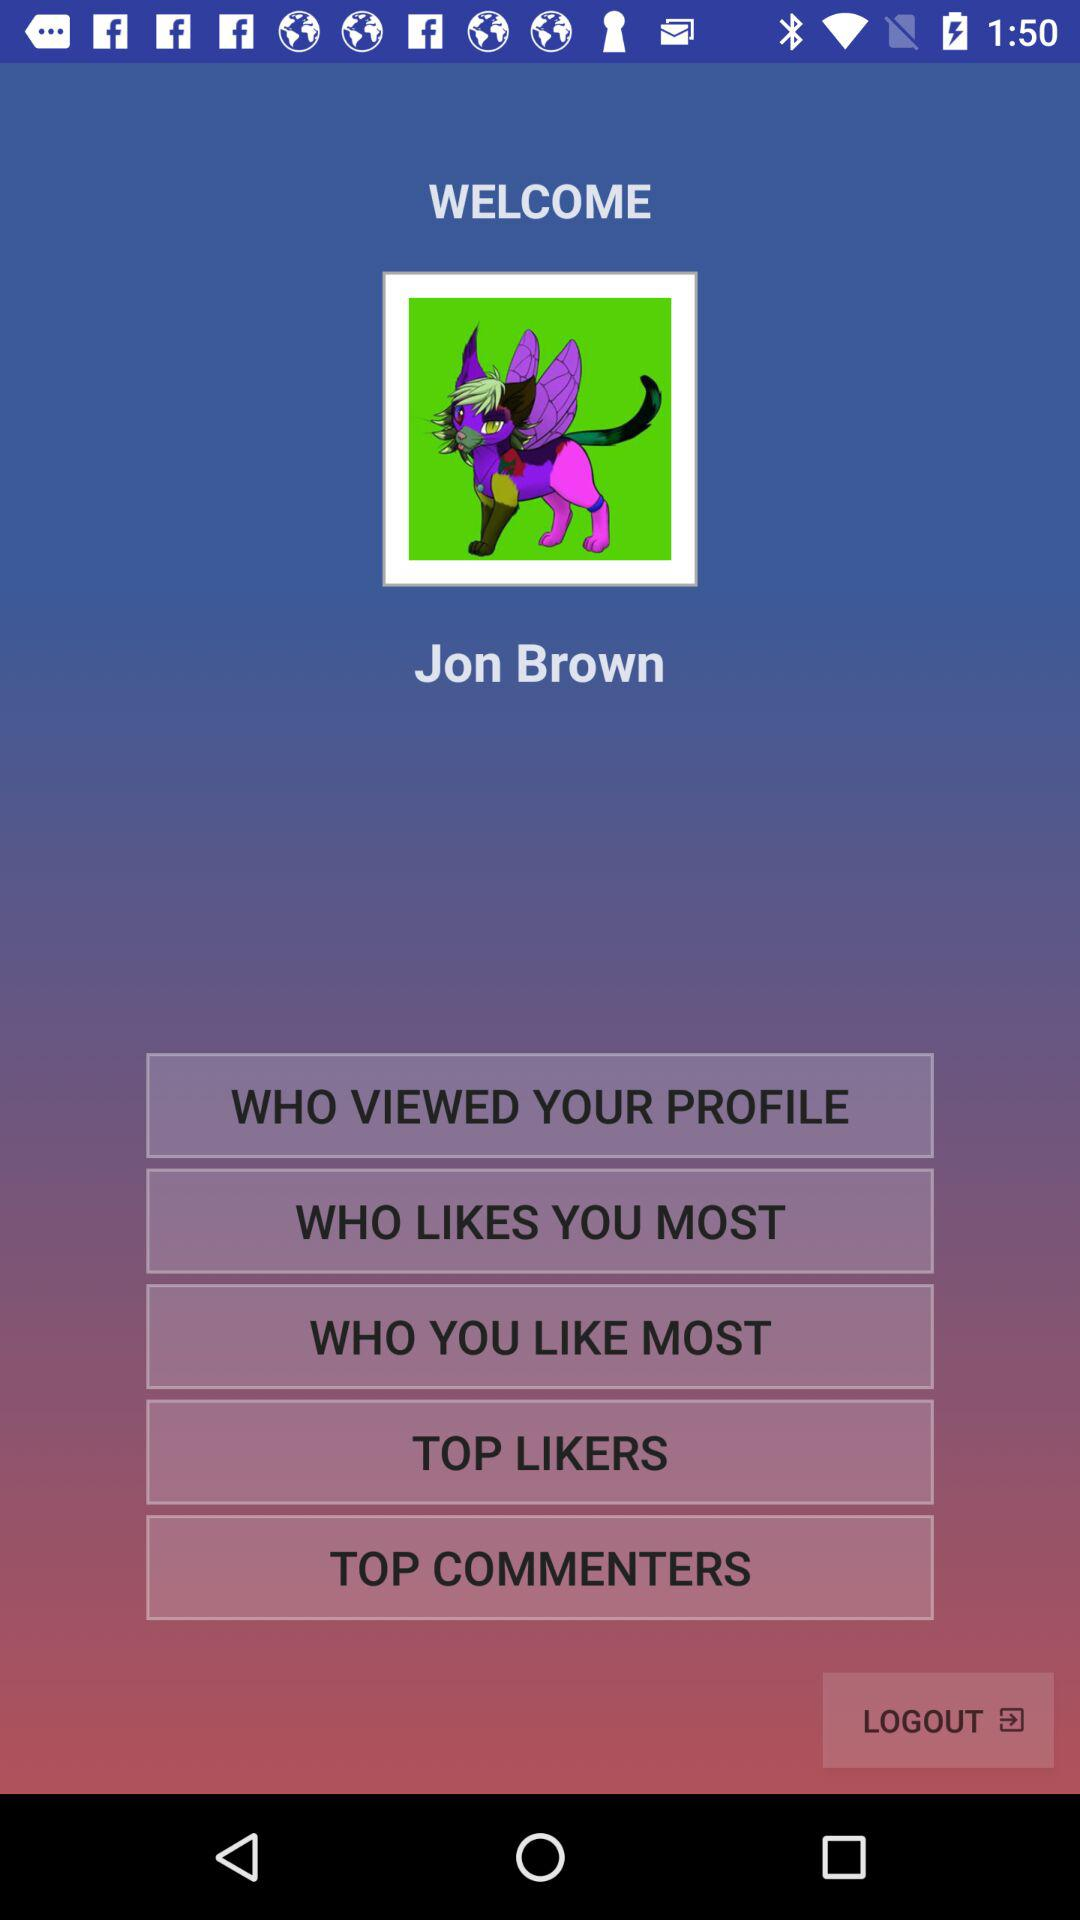How tall is Jon Brown?
When the provided information is insufficient, respond with <no answer>. <no answer> 